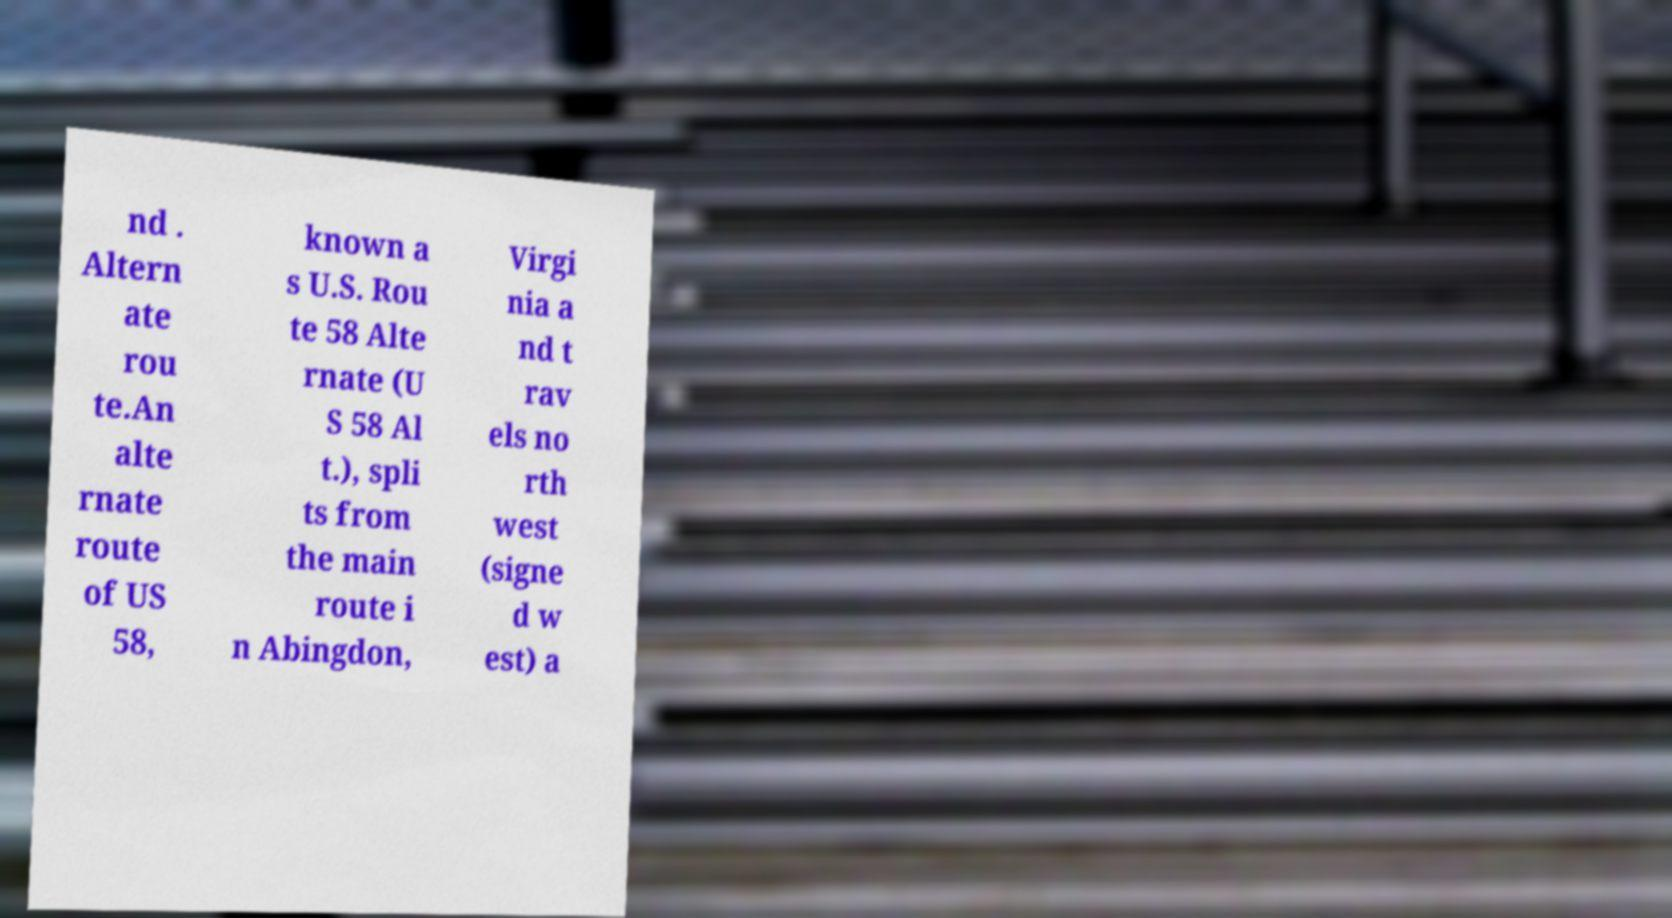For documentation purposes, I need the text within this image transcribed. Could you provide that? nd . Altern ate rou te.An alte rnate route of US 58, known a s U.S. Rou te 58 Alte rnate (U S 58 Al t.), spli ts from the main route i n Abingdon, Virgi nia a nd t rav els no rth west (signe d w est) a 